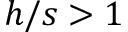Convert formula to latex. <formula><loc_0><loc_0><loc_500><loc_500>h / s > 1</formula> 